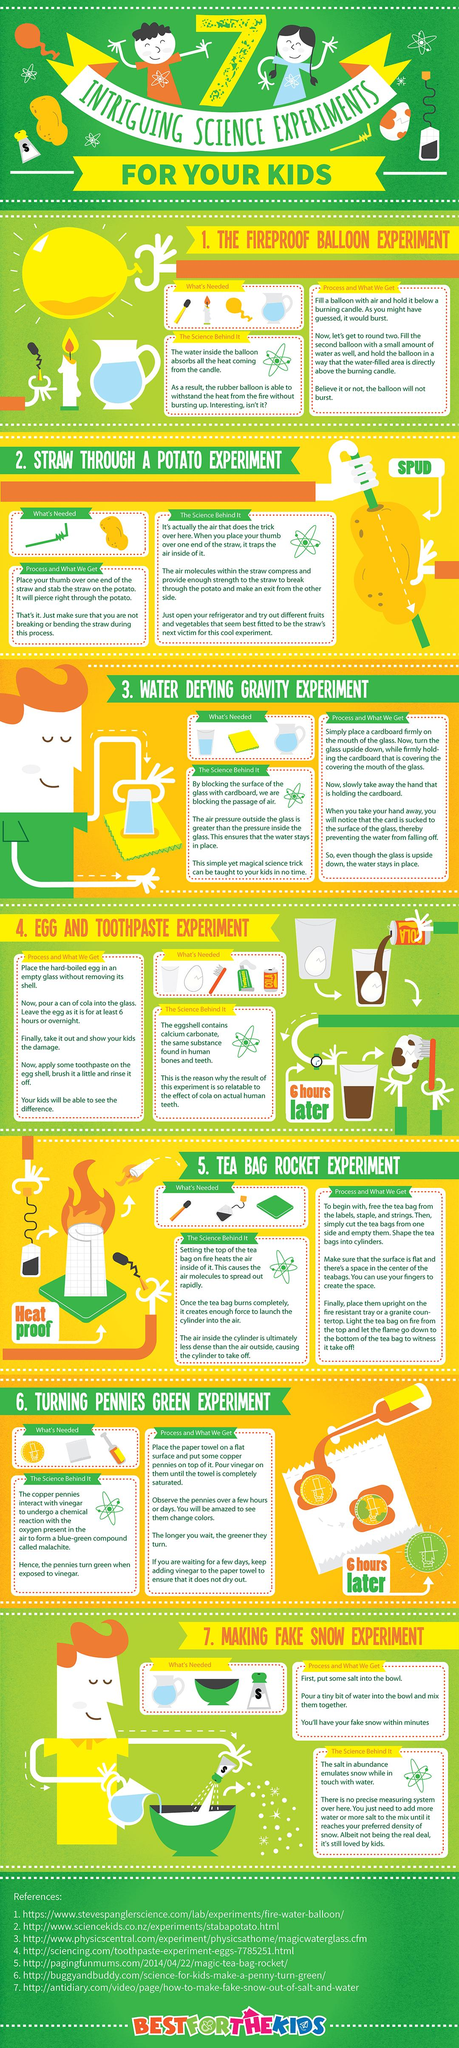Give some essential details in this illustration. The necessary components for Experiment Seven are water, a bowl, and salt. The experiment that requires the most number of things for experimenting is 4. In the egg and toothpaste experiment, a cola drink is needed as it helps to create a foaming reaction that mimics the properties of the cola solution used in the experiment. 